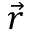Convert formula to latex. <formula><loc_0><loc_0><loc_500><loc_500>\vec { r }</formula> 